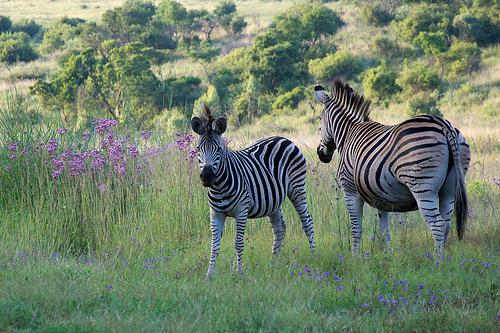Question: how many zebras are there?
Choices:
A. 2.
B. 5.
C. 6.
D. 4.
Answer with the letter. Answer: A Question: who is the smaller zebra looking at?
Choices:
A. Zoo visitors.
B. Rabbit.
C. The photographer.
D. Zulu hunters.
Answer with the letter. Answer: C Question: what are the zebras standing on?
Choices:
A. The river bank.
B. The forest floor.
C. The grass.
D. The rocks.
Answer with the letter. Answer: C Question: what pattern is on the zebras?
Choices:
A. Stripes.
B. Black and white stripes.
C. Zig zags.
D. Polka dots.
Answer with the letter. Answer: A Question: what color are the flowers?
Choices:
A. Pink.
B. Red.
C. Purple.
D. Yellow.
Answer with the letter. Answer: C Question: what color are the zebras noses?
Choices:
A. Brown.
B. Black.
C. White.
D. Gray.
Answer with the letter. Answer: B 